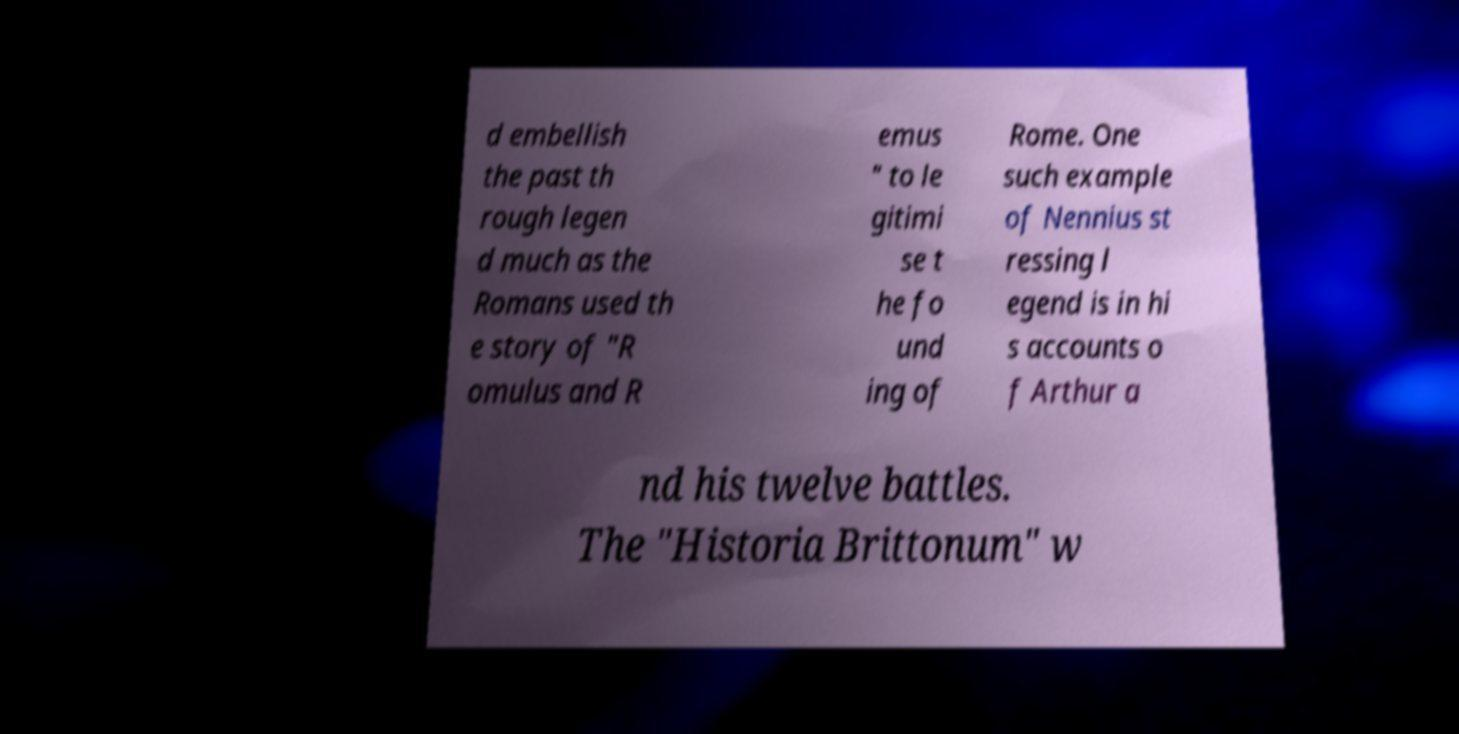Can you read and provide the text displayed in the image?This photo seems to have some interesting text. Can you extract and type it out for me? d embellish the past th rough legen d much as the Romans used th e story of "R omulus and R emus " to le gitimi se t he fo und ing of Rome. One such example of Nennius st ressing l egend is in hi s accounts o f Arthur a nd his twelve battles. The "Historia Brittonum" w 